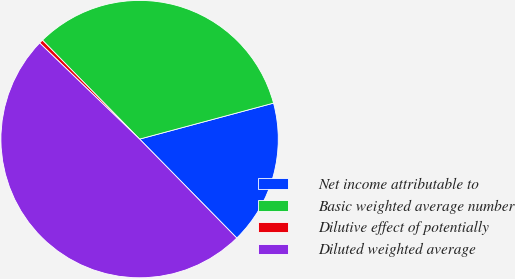<chart> <loc_0><loc_0><loc_500><loc_500><pie_chart><fcel>Net income attributable to<fcel>Basic weighted average number<fcel>Dilutive effect of potentially<fcel>Diluted weighted average<nl><fcel>16.82%<fcel>33.18%<fcel>0.45%<fcel>49.55%<nl></chart> 